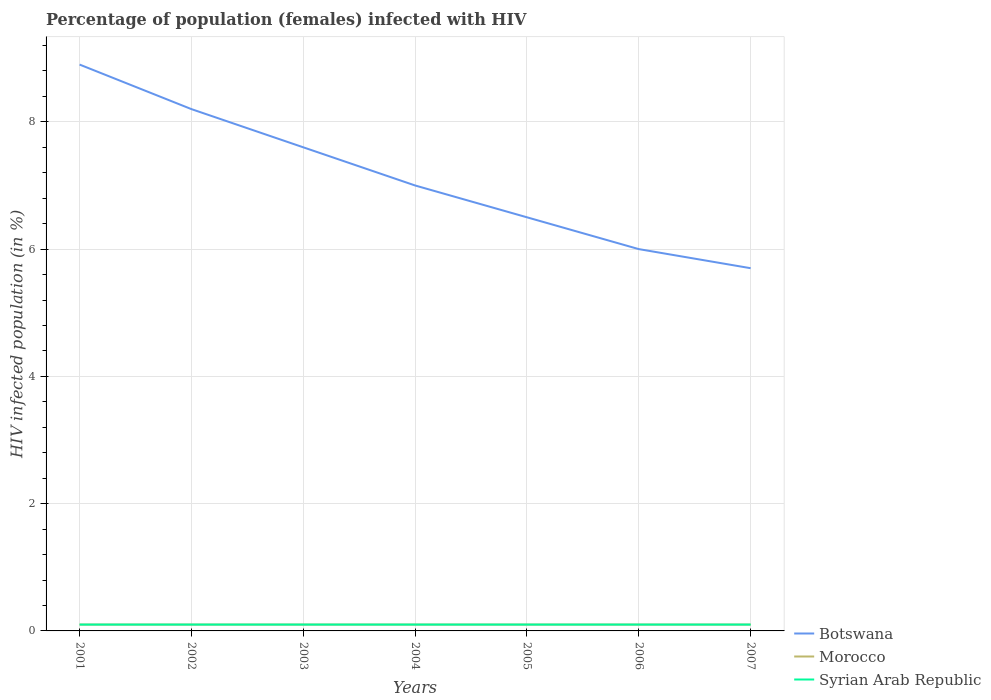Is the number of lines equal to the number of legend labels?
Give a very brief answer. Yes. Across all years, what is the maximum percentage of HIV infected female population in Morocco?
Make the answer very short. 0.1. What is the difference between the highest and the second highest percentage of HIV infected female population in Morocco?
Your answer should be very brief. 0. How many years are there in the graph?
Offer a terse response. 7. What is the difference between two consecutive major ticks on the Y-axis?
Your response must be concise. 2. Are the values on the major ticks of Y-axis written in scientific E-notation?
Provide a succinct answer. No. Where does the legend appear in the graph?
Keep it short and to the point. Bottom right. How many legend labels are there?
Your answer should be very brief. 3. How are the legend labels stacked?
Ensure brevity in your answer.  Vertical. What is the title of the graph?
Your answer should be very brief. Percentage of population (females) infected with HIV. Does "Guatemala" appear as one of the legend labels in the graph?
Your response must be concise. No. What is the label or title of the X-axis?
Make the answer very short. Years. What is the label or title of the Y-axis?
Your answer should be very brief. HIV infected population (in %). What is the HIV infected population (in %) of Morocco in 2001?
Offer a terse response. 0.1. What is the HIV infected population (in %) in Syrian Arab Republic in 2002?
Provide a short and direct response. 0.1. What is the HIV infected population (in %) in Botswana in 2003?
Keep it short and to the point. 7.6. What is the HIV infected population (in %) of Syrian Arab Republic in 2003?
Your answer should be compact. 0.1. What is the HIV infected population (in %) of Botswana in 2004?
Your answer should be very brief. 7. What is the HIV infected population (in %) in Morocco in 2004?
Ensure brevity in your answer.  0.1. What is the HIV infected population (in %) of Syrian Arab Republic in 2004?
Provide a short and direct response. 0.1. What is the HIV infected population (in %) of Morocco in 2005?
Offer a terse response. 0.1. What is the HIV infected population (in %) of Syrian Arab Republic in 2006?
Your response must be concise. 0.1. What is the HIV infected population (in %) in Botswana in 2007?
Provide a short and direct response. 5.7. What is the HIV infected population (in %) of Morocco in 2007?
Provide a succinct answer. 0.1. Across all years, what is the minimum HIV infected population (in %) in Botswana?
Give a very brief answer. 5.7. Across all years, what is the minimum HIV infected population (in %) in Morocco?
Offer a very short reply. 0.1. Across all years, what is the minimum HIV infected population (in %) in Syrian Arab Republic?
Provide a short and direct response. 0.1. What is the total HIV infected population (in %) of Botswana in the graph?
Your answer should be compact. 49.9. What is the total HIV infected population (in %) of Syrian Arab Republic in the graph?
Ensure brevity in your answer.  0.7. What is the difference between the HIV infected population (in %) of Botswana in 2001 and that in 2002?
Provide a short and direct response. 0.7. What is the difference between the HIV infected population (in %) in Syrian Arab Republic in 2001 and that in 2002?
Keep it short and to the point. 0. What is the difference between the HIV infected population (in %) in Morocco in 2001 and that in 2003?
Your answer should be compact. 0. What is the difference between the HIV infected population (in %) of Botswana in 2001 and that in 2004?
Ensure brevity in your answer.  1.9. What is the difference between the HIV infected population (in %) in Morocco in 2001 and that in 2004?
Keep it short and to the point. 0. What is the difference between the HIV infected population (in %) of Botswana in 2001 and that in 2006?
Offer a terse response. 2.9. What is the difference between the HIV infected population (in %) of Morocco in 2001 and that in 2006?
Your answer should be very brief. 0. What is the difference between the HIV infected population (in %) in Morocco in 2001 and that in 2007?
Offer a terse response. 0. What is the difference between the HIV infected population (in %) in Botswana in 2002 and that in 2003?
Your answer should be very brief. 0.6. What is the difference between the HIV infected population (in %) of Botswana in 2002 and that in 2004?
Offer a terse response. 1.2. What is the difference between the HIV infected population (in %) of Syrian Arab Republic in 2002 and that in 2004?
Offer a terse response. 0. What is the difference between the HIV infected population (in %) in Botswana in 2002 and that in 2005?
Offer a very short reply. 1.7. What is the difference between the HIV infected population (in %) of Morocco in 2002 and that in 2005?
Give a very brief answer. 0. What is the difference between the HIV infected population (in %) in Syrian Arab Republic in 2002 and that in 2005?
Your answer should be very brief. 0. What is the difference between the HIV infected population (in %) in Botswana in 2002 and that in 2006?
Make the answer very short. 2.2. What is the difference between the HIV infected population (in %) of Morocco in 2002 and that in 2006?
Provide a succinct answer. 0. What is the difference between the HIV infected population (in %) in Morocco in 2002 and that in 2007?
Ensure brevity in your answer.  0. What is the difference between the HIV infected population (in %) in Syrian Arab Republic in 2002 and that in 2007?
Give a very brief answer. 0. What is the difference between the HIV infected population (in %) in Morocco in 2003 and that in 2005?
Your answer should be compact. 0. What is the difference between the HIV infected population (in %) in Morocco in 2003 and that in 2006?
Your response must be concise. 0. What is the difference between the HIV infected population (in %) of Morocco in 2003 and that in 2007?
Make the answer very short. 0. What is the difference between the HIV infected population (in %) in Syrian Arab Republic in 2003 and that in 2007?
Your answer should be compact. 0. What is the difference between the HIV infected population (in %) in Morocco in 2004 and that in 2005?
Offer a terse response. 0. What is the difference between the HIV infected population (in %) of Syrian Arab Republic in 2004 and that in 2005?
Your answer should be very brief. 0. What is the difference between the HIV infected population (in %) of Syrian Arab Republic in 2004 and that in 2006?
Give a very brief answer. 0. What is the difference between the HIV infected population (in %) in Botswana in 2004 and that in 2007?
Offer a terse response. 1.3. What is the difference between the HIV infected population (in %) of Morocco in 2005 and that in 2006?
Your answer should be compact. 0. What is the difference between the HIV infected population (in %) of Botswana in 2005 and that in 2007?
Ensure brevity in your answer.  0.8. What is the difference between the HIV infected population (in %) in Morocco in 2005 and that in 2007?
Offer a terse response. 0. What is the difference between the HIV infected population (in %) of Morocco in 2006 and that in 2007?
Ensure brevity in your answer.  0. What is the difference between the HIV infected population (in %) of Syrian Arab Republic in 2006 and that in 2007?
Offer a very short reply. 0. What is the difference between the HIV infected population (in %) in Morocco in 2001 and the HIV infected population (in %) in Syrian Arab Republic in 2003?
Provide a succinct answer. 0. What is the difference between the HIV infected population (in %) of Botswana in 2001 and the HIV infected population (in %) of Morocco in 2004?
Ensure brevity in your answer.  8.8. What is the difference between the HIV infected population (in %) in Botswana in 2001 and the HIV infected population (in %) in Syrian Arab Republic in 2005?
Keep it short and to the point. 8.8. What is the difference between the HIV infected population (in %) in Botswana in 2001 and the HIV infected population (in %) in Syrian Arab Republic in 2006?
Provide a short and direct response. 8.8. What is the difference between the HIV infected population (in %) of Morocco in 2001 and the HIV infected population (in %) of Syrian Arab Republic in 2007?
Your response must be concise. 0. What is the difference between the HIV infected population (in %) in Botswana in 2002 and the HIV infected population (in %) in Syrian Arab Republic in 2003?
Provide a short and direct response. 8.1. What is the difference between the HIV infected population (in %) in Botswana in 2002 and the HIV infected population (in %) in Morocco in 2004?
Your answer should be very brief. 8.1. What is the difference between the HIV infected population (in %) in Botswana in 2002 and the HIV infected population (in %) in Syrian Arab Republic in 2004?
Provide a short and direct response. 8.1. What is the difference between the HIV infected population (in %) of Morocco in 2002 and the HIV infected population (in %) of Syrian Arab Republic in 2004?
Make the answer very short. 0. What is the difference between the HIV infected population (in %) of Botswana in 2002 and the HIV infected population (in %) of Morocco in 2005?
Your answer should be compact. 8.1. What is the difference between the HIV infected population (in %) in Botswana in 2002 and the HIV infected population (in %) in Syrian Arab Republic in 2005?
Give a very brief answer. 8.1. What is the difference between the HIV infected population (in %) in Botswana in 2002 and the HIV infected population (in %) in Morocco in 2006?
Give a very brief answer. 8.1. What is the difference between the HIV infected population (in %) in Botswana in 2002 and the HIV infected population (in %) in Syrian Arab Republic in 2006?
Ensure brevity in your answer.  8.1. What is the difference between the HIV infected population (in %) in Morocco in 2002 and the HIV infected population (in %) in Syrian Arab Republic in 2006?
Your response must be concise. 0. What is the difference between the HIV infected population (in %) of Botswana in 2002 and the HIV infected population (in %) of Morocco in 2007?
Give a very brief answer. 8.1. What is the difference between the HIV infected population (in %) in Botswana in 2002 and the HIV infected population (in %) in Syrian Arab Republic in 2007?
Your answer should be very brief. 8.1. What is the difference between the HIV infected population (in %) in Botswana in 2003 and the HIV infected population (in %) in Syrian Arab Republic in 2004?
Give a very brief answer. 7.5. What is the difference between the HIV infected population (in %) in Botswana in 2003 and the HIV infected population (in %) in Syrian Arab Republic in 2006?
Make the answer very short. 7.5. What is the difference between the HIV infected population (in %) of Morocco in 2003 and the HIV infected population (in %) of Syrian Arab Republic in 2006?
Provide a short and direct response. 0. What is the difference between the HIV infected population (in %) of Botswana in 2003 and the HIV infected population (in %) of Morocco in 2007?
Keep it short and to the point. 7.5. What is the difference between the HIV infected population (in %) in Morocco in 2003 and the HIV infected population (in %) in Syrian Arab Republic in 2007?
Offer a terse response. 0. What is the difference between the HIV infected population (in %) of Botswana in 2004 and the HIV infected population (in %) of Morocco in 2005?
Keep it short and to the point. 6.9. What is the difference between the HIV infected population (in %) of Botswana in 2004 and the HIV infected population (in %) of Morocco in 2006?
Give a very brief answer. 6.9. What is the difference between the HIV infected population (in %) in Botswana in 2004 and the HIV infected population (in %) in Morocco in 2007?
Provide a succinct answer. 6.9. What is the difference between the HIV infected population (in %) of Botswana in 2004 and the HIV infected population (in %) of Syrian Arab Republic in 2007?
Your response must be concise. 6.9. What is the difference between the HIV infected population (in %) of Botswana in 2005 and the HIV infected population (in %) of Syrian Arab Republic in 2006?
Give a very brief answer. 6.4. What is the difference between the HIV infected population (in %) in Morocco in 2005 and the HIV infected population (in %) in Syrian Arab Republic in 2006?
Your answer should be very brief. 0. What is the difference between the HIV infected population (in %) of Botswana in 2005 and the HIV infected population (in %) of Morocco in 2007?
Your answer should be very brief. 6.4. What is the difference between the HIV infected population (in %) in Morocco in 2005 and the HIV infected population (in %) in Syrian Arab Republic in 2007?
Make the answer very short. 0. What is the difference between the HIV infected population (in %) of Botswana in 2006 and the HIV infected population (in %) of Morocco in 2007?
Make the answer very short. 5.9. What is the difference between the HIV infected population (in %) in Morocco in 2006 and the HIV infected population (in %) in Syrian Arab Republic in 2007?
Your response must be concise. 0. What is the average HIV infected population (in %) of Botswana per year?
Offer a very short reply. 7.13. What is the average HIV infected population (in %) in Morocco per year?
Give a very brief answer. 0.1. What is the average HIV infected population (in %) in Syrian Arab Republic per year?
Provide a succinct answer. 0.1. In the year 2001, what is the difference between the HIV infected population (in %) in Botswana and HIV infected population (in %) in Morocco?
Ensure brevity in your answer.  8.8. In the year 2001, what is the difference between the HIV infected population (in %) in Morocco and HIV infected population (in %) in Syrian Arab Republic?
Your answer should be very brief. 0. In the year 2003, what is the difference between the HIV infected population (in %) in Botswana and HIV infected population (in %) in Morocco?
Your answer should be compact. 7.5. In the year 2004, what is the difference between the HIV infected population (in %) of Botswana and HIV infected population (in %) of Morocco?
Make the answer very short. 6.9. In the year 2005, what is the difference between the HIV infected population (in %) of Botswana and HIV infected population (in %) of Morocco?
Provide a short and direct response. 6.4. In the year 2006, what is the difference between the HIV infected population (in %) of Botswana and HIV infected population (in %) of Syrian Arab Republic?
Your response must be concise. 5.9. In the year 2007, what is the difference between the HIV infected population (in %) in Morocco and HIV infected population (in %) in Syrian Arab Republic?
Make the answer very short. 0. What is the ratio of the HIV infected population (in %) of Botswana in 2001 to that in 2002?
Provide a succinct answer. 1.09. What is the ratio of the HIV infected population (in %) in Morocco in 2001 to that in 2002?
Provide a short and direct response. 1. What is the ratio of the HIV infected population (in %) of Syrian Arab Republic in 2001 to that in 2002?
Provide a succinct answer. 1. What is the ratio of the HIV infected population (in %) of Botswana in 2001 to that in 2003?
Your response must be concise. 1.17. What is the ratio of the HIV infected population (in %) of Syrian Arab Republic in 2001 to that in 2003?
Make the answer very short. 1. What is the ratio of the HIV infected population (in %) of Botswana in 2001 to that in 2004?
Offer a terse response. 1.27. What is the ratio of the HIV infected population (in %) of Syrian Arab Republic in 2001 to that in 2004?
Make the answer very short. 1. What is the ratio of the HIV infected population (in %) in Botswana in 2001 to that in 2005?
Offer a very short reply. 1.37. What is the ratio of the HIV infected population (in %) of Syrian Arab Republic in 2001 to that in 2005?
Ensure brevity in your answer.  1. What is the ratio of the HIV infected population (in %) of Botswana in 2001 to that in 2006?
Provide a short and direct response. 1.48. What is the ratio of the HIV infected population (in %) of Morocco in 2001 to that in 2006?
Make the answer very short. 1. What is the ratio of the HIV infected population (in %) in Syrian Arab Republic in 2001 to that in 2006?
Ensure brevity in your answer.  1. What is the ratio of the HIV infected population (in %) in Botswana in 2001 to that in 2007?
Provide a short and direct response. 1.56. What is the ratio of the HIV infected population (in %) of Botswana in 2002 to that in 2003?
Your response must be concise. 1.08. What is the ratio of the HIV infected population (in %) of Syrian Arab Republic in 2002 to that in 2003?
Your answer should be compact. 1. What is the ratio of the HIV infected population (in %) of Botswana in 2002 to that in 2004?
Offer a terse response. 1.17. What is the ratio of the HIV infected population (in %) of Syrian Arab Republic in 2002 to that in 2004?
Your answer should be compact. 1. What is the ratio of the HIV infected population (in %) in Botswana in 2002 to that in 2005?
Your response must be concise. 1.26. What is the ratio of the HIV infected population (in %) in Syrian Arab Republic in 2002 to that in 2005?
Your response must be concise. 1. What is the ratio of the HIV infected population (in %) in Botswana in 2002 to that in 2006?
Ensure brevity in your answer.  1.37. What is the ratio of the HIV infected population (in %) of Syrian Arab Republic in 2002 to that in 2006?
Make the answer very short. 1. What is the ratio of the HIV infected population (in %) of Botswana in 2002 to that in 2007?
Offer a very short reply. 1.44. What is the ratio of the HIV infected population (in %) in Morocco in 2002 to that in 2007?
Provide a short and direct response. 1. What is the ratio of the HIV infected population (in %) of Syrian Arab Republic in 2002 to that in 2007?
Provide a short and direct response. 1. What is the ratio of the HIV infected population (in %) of Botswana in 2003 to that in 2004?
Provide a short and direct response. 1.09. What is the ratio of the HIV infected population (in %) in Morocco in 2003 to that in 2004?
Your answer should be compact. 1. What is the ratio of the HIV infected population (in %) of Syrian Arab Republic in 2003 to that in 2004?
Provide a short and direct response. 1. What is the ratio of the HIV infected population (in %) in Botswana in 2003 to that in 2005?
Provide a succinct answer. 1.17. What is the ratio of the HIV infected population (in %) of Syrian Arab Republic in 2003 to that in 2005?
Offer a terse response. 1. What is the ratio of the HIV infected population (in %) of Botswana in 2003 to that in 2006?
Your answer should be compact. 1.27. What is the ratio of the HIV infected population (in %) of Syrian Arab Republic in 2003 to that in 2006?
Offer a terse response. 1. What is the ratio of the HIV infected population (in %) of Botswana in 2003 to that in 2007?
Your answer should be very brief. 1.33. What is the ratio of the HIV infected population (in %) in Morocco in 2003 to that in 2007?
Your answer should be very brief. 1. What is the ratio of the HIV infected population (in %) of Syrian Arab Republic in 2003 to that in 2007?
Your response must be concise. 1. What is the ratio of the HIV infected population (in %) of Botswana in 2004 to that in 2006?
Offer a terse response. 1.17. What is the ratio of the HIV infected population (in %) of Syrian Arab Republic in 2004 to that in 2006?
Make the answer very short. 1. What is the ratio of the HIV infected population (in %) in Botswana in 2004 to that in 2007?
Offer a very short reply. 1.23. What is the ratio of the HIV infected population (in %) in Morocco in 2004 to that in 2007?
Your response must be concise. 1. What is the ratio of the HIV infected population (in %) in Botswana in 2005 to that in 2006?
Your response must be concise. 1.08. What is the ratio of the HIV infected population (in %) of Syrian Arab Republic in 2005 to that in 2006?
Provide a short and direct response. 1. What is the ratio of the HIV infected population (in %) of Botswana in 2005 to that in 2007?
Make the answer very short. 1.14. What is the ratio of the HIV infected population (in %) of Botswana in 2006 to that in 2007?
Your answer should be compact. 1.05. What is the ratio of the HIV infected population (in %) in Syrian Arab Republic in 2006 to that in 2007?
Your answer should be very brief. 1. What is the difference between the highest and the second highest HIV infected population (in %) of Botswana?
Offer a terse response. 0.7. What is the difference between the highest and the second highest HIV infected population (in %) of Morocco?
Offer a very short reply. 0. What is the difference between the highest and the lowest HIV infected population (in %) in Morocco?
Make the answer very short. 0. What is the difference between the highest and the lowest HIV infected population (in %) in Syrian Arab Republic?
Make the answer very short. 0. 